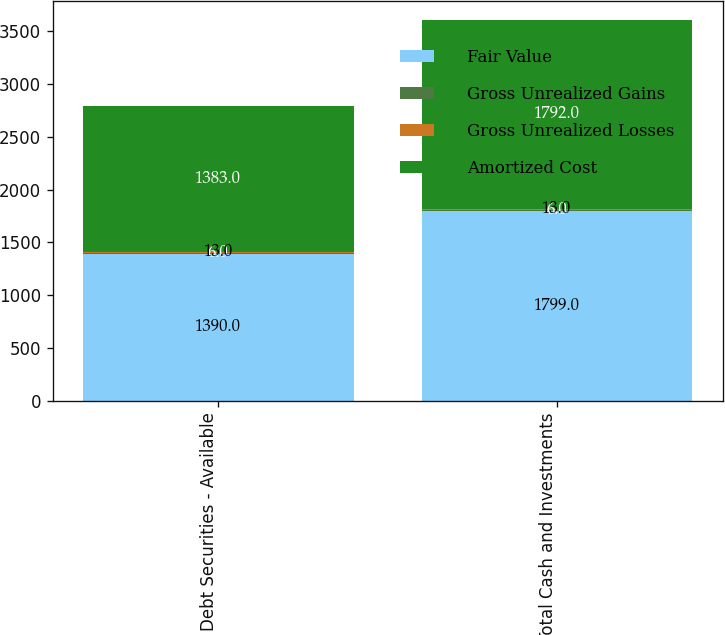Convert chart to OTSL. <chart><loc_0><loc_0><loc_500><loc_500><stacked_bar_chart><ecel><fcel>Debt Securities - Available<fcel>Total Cash and Investments<nl><fcel>Fair Value<fcel>1390<fcel>1799<nl><fcel>Gross Unrealized Gains<fcel>6<fcel>6<nl><fcel>Gross Unrealized Losses<fcel>13<fcel>13<nl><fcel>Amortized Cost<fcel>1383<fcel>1792<nl></chart> 